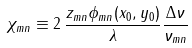Convert formula to latex. <formula><loc_0><loc_0><loc_500><loc_500>\chi _ { m n } \equiv 2 \, \frac { z _ { m n } \phi _ { m n } ( x _ { 0 } , y _ { 0 } ) } { \lambda } \frac { \Delta \nu } { \nu _ { m n } }</formula> 